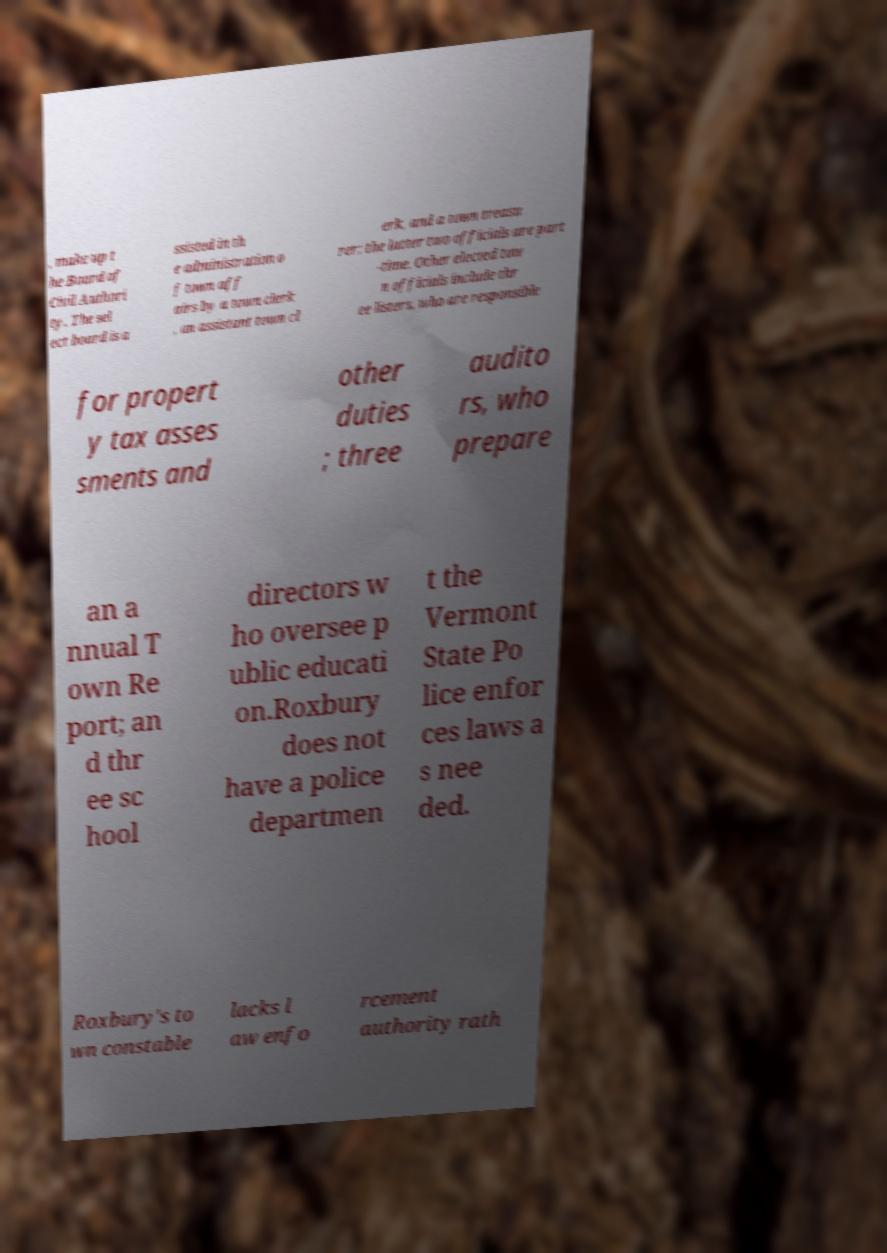I need the written content from this picture converted into text. Can you do that? , make up t he Board of Civil Authori ty. The sel ect board is a ssisted in th e administration o f town aff airs by a town clerk , an assistant town cl erk, and a town treasu rer; the latter two officials are part -time. Other elected tow n officials include thr ee listers, who are responsible for propert y tax asses sments and other duties ; three audito rs, who prepare an a nnual T own Re port; an d thr ee sc hool directors w ho oversee p ublic educati on.Roxbury does not have a police departmen t the Vermont State Po lice enfor ces laws a s nee ded. Roxbury's to wn constable lacks l aw enfo rcement authority rath 